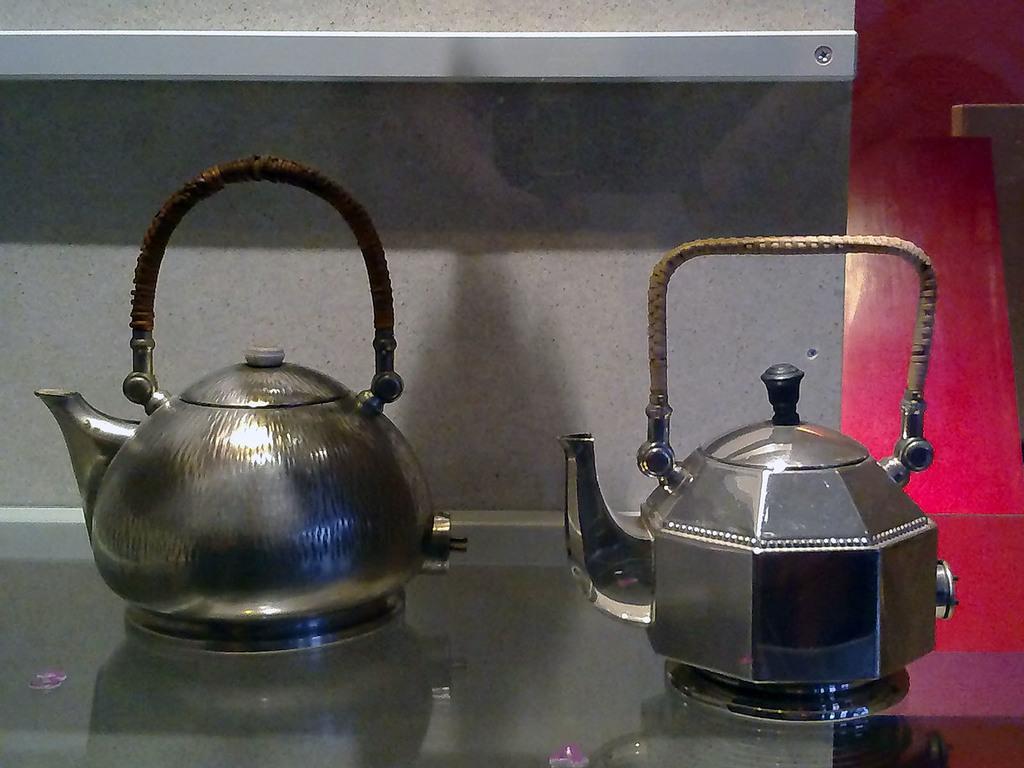Can you describe this image briefly? On this surface we can see teapots. Background there is a wall. 